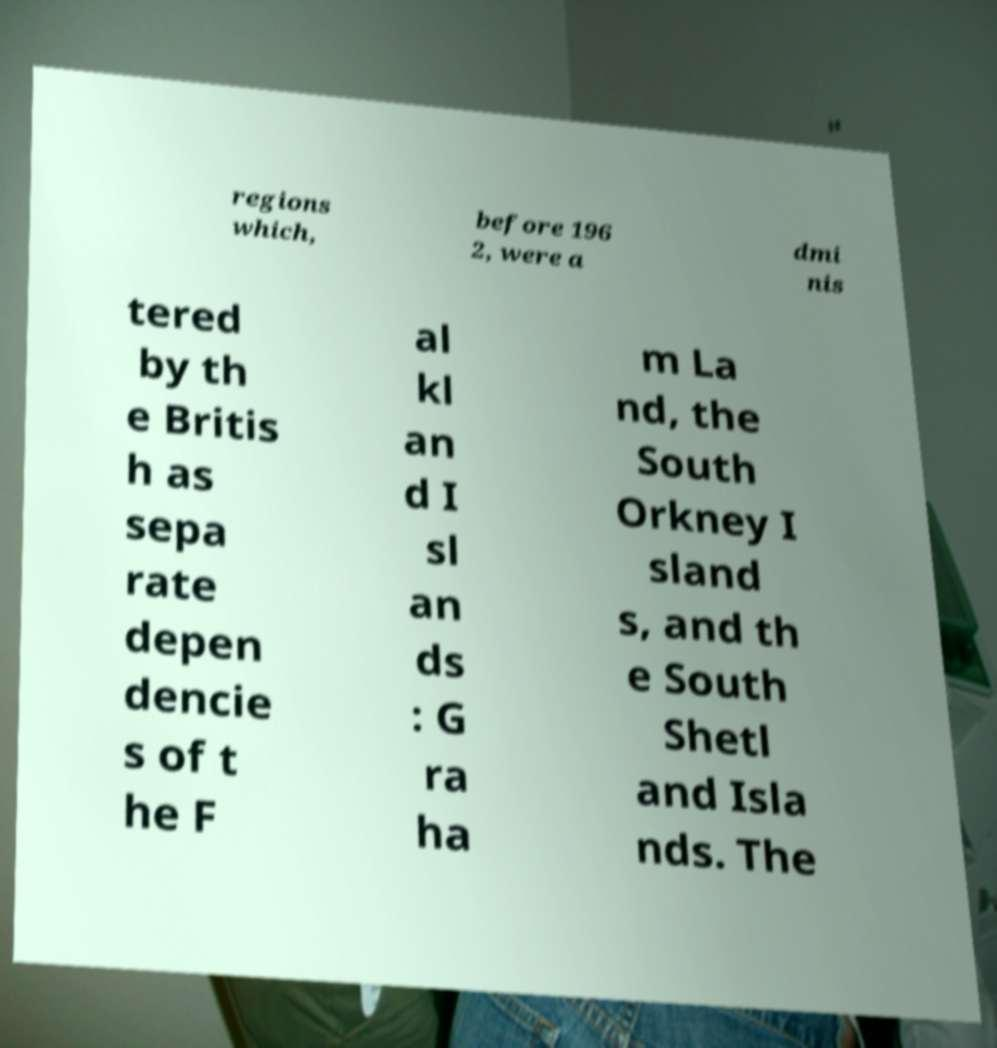Please identify and transcribe the text found in this image. regions which, before 196 2, were a dmi nis tered by th e Britis h as sepa rate depen dencie s of t he F al kl an d I sl an ds : G ra ha m La nd, the South Orkney I sland s, and th e South Shetl and Isla nds. The 